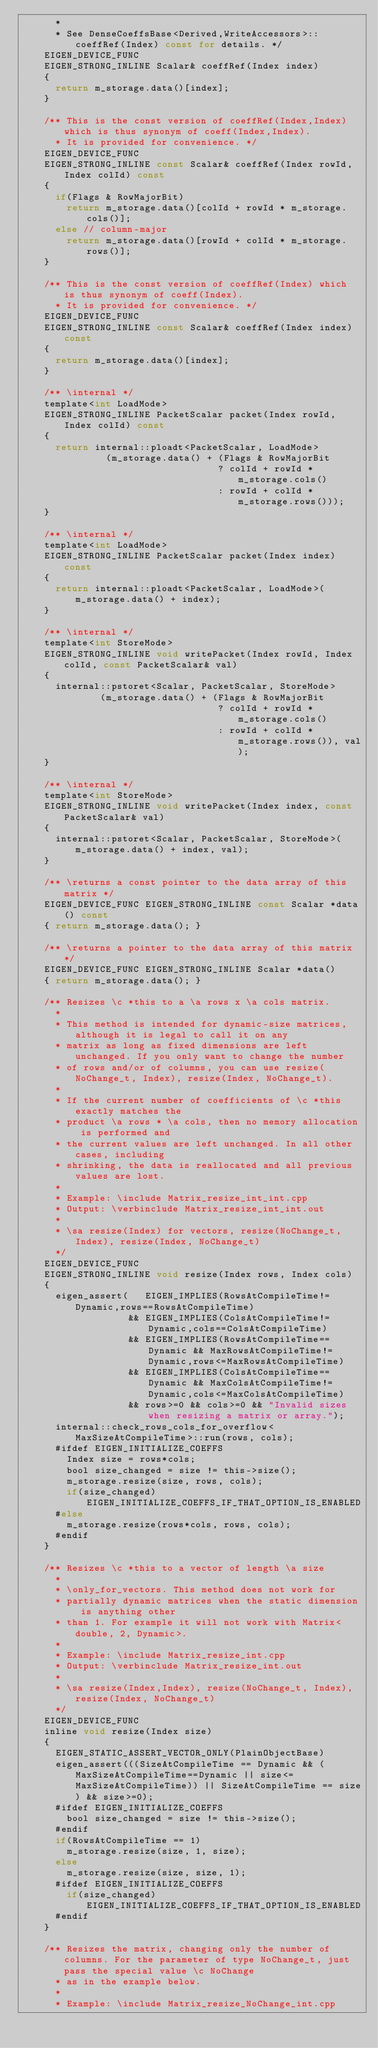<code> <loc_0><loc_0><loc_500><loc_500><_C_>      *
      * See DenseCoeffsBase<Derived,WriteAccessors>::coeffRef(Index) const for details. */
    EIGEN_DEVICE_FUNC
    EIGEN_STRONG_INLINE Scalar& coeffRef(Index index)
    {
      return m_storage.data()[index];
    }

    /** This is the const version of coeffRef(Index,Index) which is thus synonym of coeff(Index,Index).
      * It is provided for convenience. */
    EIGEN_DEVICE_FUNC
    EIGEN_STRONG_INLINE const Scalar& coeffRef(Index rowId, Index colId) const
    {
      if(Flags & RowMajorBit)
        return m_storage.data()[colId + rowId * m_storage.cols()];
      else // column-major
        return m_storage.data()[rowId + colId * m_storage.rows()];
    }

    /** This is the const version of coeffRef(Index) which is thus synonym of coeff(Index).
      * It is provided for convenience. */
    EIGEN_DEVICE_FUNC
    EIGEN_STRONG_INLINE const Scalar& coeffRef(Index index) const
    {
      return m_storage.data()[index];
    }

    /** \internal */
    template<int LoadMode>
    EIGEN_STRONG_INLINE PacketScalar packet(Index rowId, Index colId) const
    {
      return internal::ploadt<PacketScalar, LoadMode>
               (m_storage.data() + (Flags & RowMajorBit
                                   ? colId + rowId * m_storage.cols()
                                   : rowId + colId * m_storage.rows()));
    }

    /** \internal */
    template<int LoadMode>
    EIGEN_STRONG_INLINE PacketScalar packet(Index index) const
    {
      return internal::ploadt<PacketScalar, LoadMode>(m_storage.data() + index);
    }

    /** \internal */
    template<int StoreMode>
    EIGEN_STRONG_INLINE void writePacket(Index rowId, Index colId, const PacketScalar& val)
    {
      internal::pstoret<Scalar, PacketScalar, StoreMode>
              (m_storage.data() + (Flags & RowMajorBit
                                   ? colId + rowId * m_storage.cols()
                                   : rowId + colId * m_storage.rows()), val);
    }

    /** \internal */
    template<int StoreMode>
    EIGEN_STRONG_INLINE void writePacket(Index index, const PacketScalar& val)
    {
      internal::pstoret<Scalar, PacketScalar, StoreMode>(m_storage.data() + index, val);
    }

    /** \returns a const pointer to the data array of this matrix */
    EIGEN_DEVICE_FUNC EIGEN_STRONG_INLINE const Scalar *data() const
    { return m_storage.data(); }

    /** \returns a pointer to the data array of this matrix */
    EIGEN_DEVICE_FUNC EIGEN_STRONG_INLINE Scalar *data()
    { return m_storage.data(); }

    /** Resizes \c *this to a \a rows x \a cols matrix.
      *
      * This method is intended for dynamic-size matrices, although it is legal to call it on any
      * matrix as long as fixed dimensions are left unchanged. If you only want to change the number
      * of rows and/or of columns, you can use resize(NoChange_t, Index), resize(Index, NoChange_t).
      *
      * If the current number of coefficients of \c *this exactly matches the
      * product \a rows * \a cols, then no memory allocation is performed and
      * the current values are left unchanged. In all other cases, including
      * shrinking, the data is reallocated and all previous values are lost.
      *
      * Example: \include Matrix_resize_int_int.cpp
      * Output: \verbinclude Matrix_resize_int_int.out
      *
      * \sa resize(Index) for vectors, resize(NoChange_t, Index), resize(Index, NoChange_t)
      */
    EIGEN_DEVICE_FUNC
    EIGEN_STRONG_INLINE void resize(Index rows, Index cols)
    {
      eigen_assert(   EIGEN_IMPLIES(RowsAtCompileTime!=Dynamic,rows==RowsAtCompileTime)
                   && EIGEN_IMPLIES(ColsAtCompileTime!=Dynamic,cols==ColsAtCompileTime)
                   && EIGEN_IMPLIES(RowsAtCompileTime==Dynamic && MaxRowsAtCompileTime!=Dynamic,rows<=MaxRowsAtCompileTime)
                   && EIGEN_IMPLIES(ColsAtCompileTime==Dynamic && MaxColsAtCompileTime!=Dynamic,cols<=MaxColsAtCompileTime)
                   && rows>=0 && cols>=0 && "Invalid sizes when resizing a matrix or array.");
      internal::check_rows_cols_for_overflow<MaxSizeAtCompileTime>::run(rows, cols);
      #ifdef EIGEN_INITIALIZE_COEFFS
        Index size = rows*cols;
        bool size_changed = size != this->size();
        m_storage.resize(size, rows, cols);
        if(size_changed) EIGEN_INITIALIZE_COEFFS_IF_THAT_OPTION_IS_ENABLED
      #else
        m_storage.resize(rows*cols, rows, cols);
      #endif
    }

    /** Resizes \c *this to a vector of length \a size
      *
      * \only_for_vectors. This method does not work for
      * partially dynamic matrices when the static dimension is anything other
      * than 1. For example it will not work with Matrix<double, 2, Dynamic>.
      *
      * Example: \include Matrix_resize_int.cpp
      * Output: \verbinclude Matrix_resize_int.out
      *
      * \sa resize(Index,Index), resize(NoChange_t, Index), resize(Index, NoChange_t)
      */
    EIGEN_DEVICE_FUNC
    inline void resize(Index size)
    {
      EIGEN_STATIC_ASSERT_VECTOR_ONLY(PlainObjectBase)
      eigen_assert(((SizeAtCompileTime == Dynamic && (MaxSizeAtCompileTime==Dynamic || size<=MaxSizeAtCompileTime)) || SizeAtCompileTime == size) && size>=0);
      #ifdef EIGEN_INITIALIZE_COEFFS
        bool size_changed = size != this->size();
      #endif
      if(RowsAtCompileTime == 1)
        m_storage.resize(size, 1, size);
      else
        m_storage.resize(size, size, 1);
      #ifdef EIGEN_INITIALIZE_COEFFS
        if(size_changed) EIGEN_INITIALIZE_COEFFS_IF_THAT_OPTION_IS_ENABLED
      #endif
    }

    /** Resizes the matrix, changing only the number of columns. For the parameter of type NoChange_t, just pass the special value \c NoChange
      * as in the example below.
      *
      * Example: \include Matrix_resize_NoChange_int.cpp</code> 